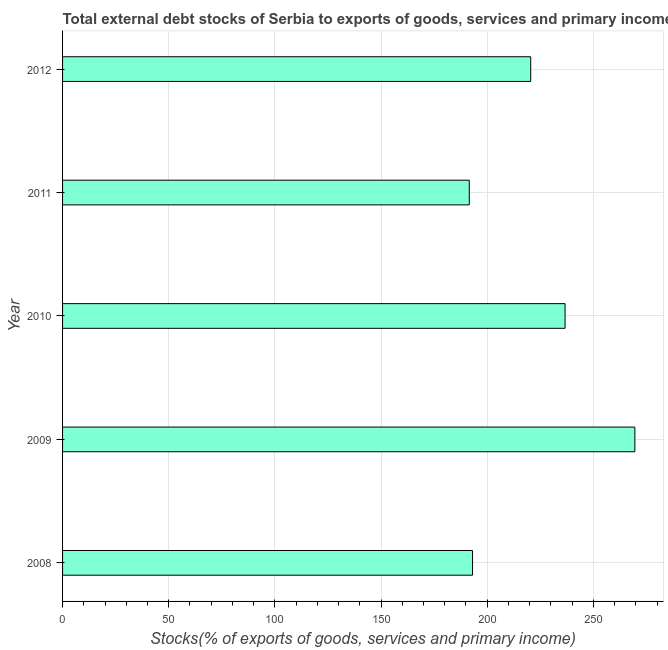Does the graph contain any zero values?
Keep it short and to the point. No. What is the title of the graph?
Make the answer very short. Total external debt stocks of Serbia to exports of goods, services and primary income. What is the label or title of the X-axis?
Ensure brevity in your answer.  Stocks(% of exports of goods, services and primary income). What is the external debt stocks in 2011?
Your answer should be very brief. 191.56. Across all years, what is the maximum external debt stocks?
Keep it short and to the point. 269.55. Across all years, what is the minimum external debt stocks?
Provide a succinct answer. 191.56. What is the sum of the external debt stocks?
Your answer should be very brief. 1111.37. What is the difference between the external debt stocks in 2009 and 2010?
Make the answer very short. 32.89. What is the average external debt stocks per year?
Provide a short and direct response. 222.27. What is the median external debt stocks?
Your response must be concise. 220.5. In how many years, is the external debt stocks greater than 100 %?
Make the answer very short. 5. Do a majority of the years between 2011 and 2010 (inclusive) have external debt stocks greater than 10 %?
Provide a succinct answer. No. What is the ratio of the external debt stocks in 2011 to that in 2012?
Ensure brevity in your answer.  0.87. Is the external debt stocks in 2008 less than that in 2011?
Provide a short and direct response. No. What is the difference between the highest and the second highest external debt stocks?
Offer a terse response. 32.89. What is the difference between the highest and the lowest external debt stocks?
Provide a succinct answer. 77.99. In how many years, is the external debt stocks greater than the average external debt stocks taken over all years?
Keep it short and to the point. 2. How many bars are there?
Your answer should be compact. 5. How many years are there in the graph?
Give a very brief answer. 5. Are the values on the major ticks of X-axis written in scientific E-notation?
Give a very brief answer. No. What is the Stocks(% of exports of goods, services and primary income) of 2008?
Your response must be concise. 193.09. What is the Stocks(% of exports of goods, services and primary income) of 2009?
Make the answer very short. 269.55. What is the Stocks(% of exports of goods, services and primary income) of 2010?
Make the answer very short. 236.67. What is the Stocks(% of exports of goods, services and primary income) of 2011?
Your response must be concise. 191.56. What is the Stocks(% of exports of goods, services and primary income) of 2012?
Offer a terse response. 220.5. What is the difference between the Stocks(% of exports of goods, services and primary income) in 2008 and 2009?
Keep it short and to the point. -76.47. What is the difference between the Stocks(% of exports of goods, services and primary income) in 2008 and 2010?
Make the answer very short. -43.58. What is the difference between the Stocks(% of exports of goods, services and primary income) in 2008 and 2011?
Offer a terse response. 1.53. What is the difference between the Stocks(% of exports of goods, services and primary income) in 2008 and 2012?
Your response must be concise. -27.41. What is the difference between the Stocks(% of exports of goods, services and primary income) in 2009 and 2010?
Offer a terse response. 32.89. What is the difference between the Stocks(% of exports of goods, services and primary income) in 2009 and 2011?
Offer a very short reply. 77.99. What is the difference between the Stocks(% of exports of goods, services and primary income) in 2009 and 2012?
Your answer should be very brief. 49.06. What is the difference between the Stocks(% of exports of goods, services and primary income) in 2010 and 2011?
Provide a succinct answer. 45.11. What is the difference between the Stocks(% of exports of goods, services and primary income) in 2010 and 2012?
Provide a succinct answer. 16.17. What is the difference between the Stocks(% of exports of goods, services and primary income) in 2011 and 2012?
Provide a short and direct response. -28.94. What is the ratio of the Stocks(% of exports of goods, services and primary income) in 2008 to that in 2009?
Offer a terse response. 0.72. What is the ratio of the Stocks(% of exports of goods, services and primary income) in 2008 to that in 2010?
Provide a succinct answer. 0.82. What is the ratio of the Stocks(% of exports of goods, services and primary income) in 2008 to that in 2012?
Provide a succinct answer. 0.88. What is the ratio of the Stocks(% of exports of goods, services and primary income) in 2009 to that in 2010?
Provide a succinct answer. 1.14. What is the ratio of the Stocks(% of exports of goods, services and primary income) in 2009 to that in 2011?
Your response must be concise. 1.41. What is the ratio of the Stocks(% of exports of goods, services and primary income) in 2009 to that in 2012?
Give a very brief answer. 1.22. What is the ratio of the Stocks(% of exports of goods, services and primary income) in 2010 to that in 2011?
Your response must be concise. 1.24. What is the ratio of the Stocks(% of exports of goods, services and primary income) in 2010 to that in 2012?
Offer a very short reply. 1.07. What is the ratio of the Stocks(% of exports of goods, services and primary income) in 2011 to that in 2012?
Your response must be concise. 0.87. 